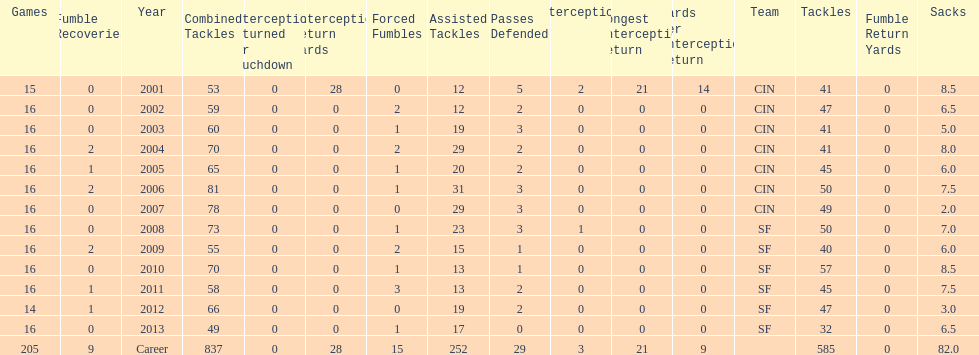How many consecutive years were there 20 or more assisted tackles? 5. 